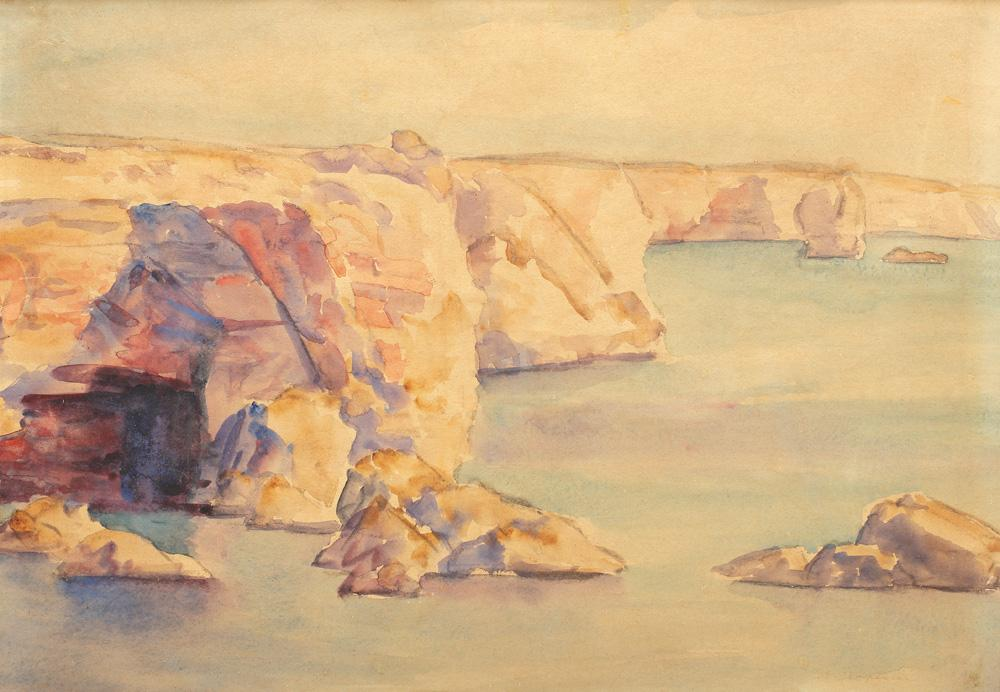Describe the following image.
 The image is a watercolor painting that vividly captures a rocky coastline. The artist has employed a loose, impressionistic style, allowing the colors and textures to tell the story of the landscape. The palette is dominated by warm hues, with yellows, oranges, and reds creating a sense of warmth and light. These colors contrast beautifully with the cooler tones of the water, enhancing the overall visual impact of the painting. The painting falls under the landscape or seascape genre, a common theme in art that focuses on the natural world. The artist's skillful use of watercolors brings the scene to life, making it a captivating piece of art. 